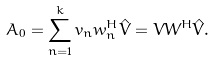<formula> <loc_0><loc_0><loc_500><loc_500>A _ { 0 } = \sum _ { n = 1 } ^ { k } v _ { n } w _ { n } ^ { H } \hat { V } = V W ^ { H } \hat { V } .</formula> 